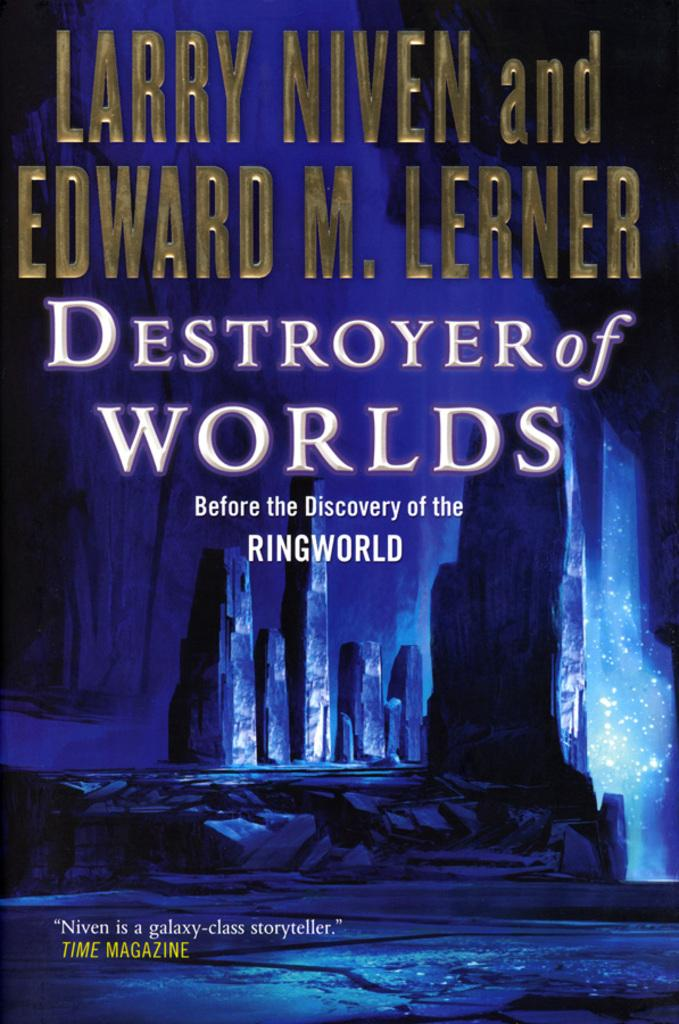<image>
Provide a brief description of the given image. The name of the book by Niven and Lerner is "Destroyer of Worlds". 